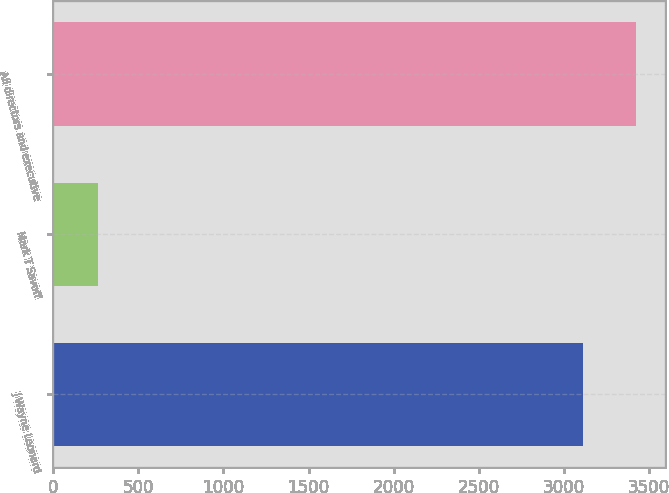<chart> <loc_0><loc_0><loc_500><loc_500><bar_chart><fcel>J Wayne Leonard<fcel>Mark T Savoff<fcel>All directors and executive<nl><fcel>3111<fcel>263<fcel>3422.1<nl></chart> 